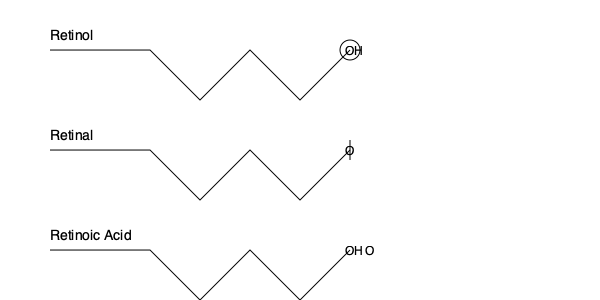Based on the molecular diagrams shown, which retinoid derivative is likely to be the most potent in terms of its effects on skin cell turnover and collagen production? To answer this question, we need to consider the chemical structures of the three retinoid derivatives and their relative potency:

1. Retinol: This is the basic form of vitamin A. It has an alcohol group (-OH) at the end of the molecule.

2. Retinal: This is the aldehyde form of vitamin A. It has an aldehyde group (-CHO) at the end of the molecule.

3. Retinoic Acid: This is the acid form of vitamin A. It has a carboxylic acid group (-COOH) at the end of the molecule.

The potency of retinoids is related to their ability to bind to and activate retinoic acid receptors (RARs) in skin cells. The more easily a retinoid can bind to these receptors, the more potent its effects will be.

Retinoic acid is the most potent because:
1. It can directly bind to RARs without any conversion.
2. Its carboxylic acid group allows for stronger binding to the receptors.

Retinal is the second most potent because it only needs one oxidation step to become retinoic acid.

Retinol is the least potent because it requires two conversion steps to become retinoic acid:
Retinol → Retinal → Retinoic Acid

Therefore, retinoic acid is likely to be the most potent in terms of its effects on skin cell turnover and collagen production.
Answer: Retinoic Acid 